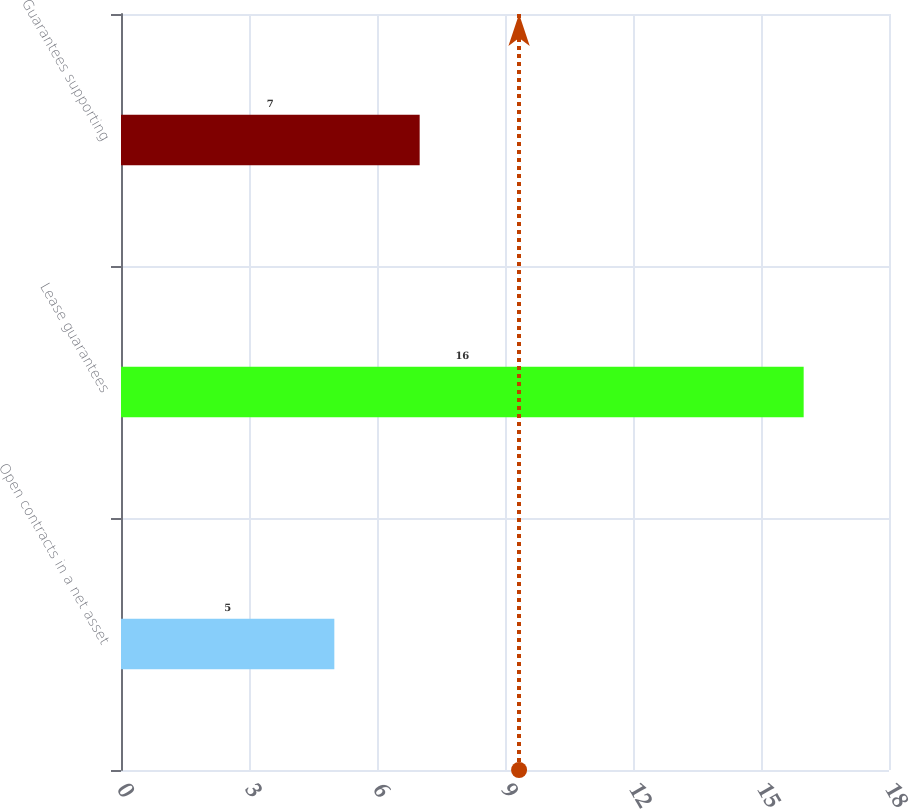<chart> <loc_0><loc_0><loc_500><loc_500><bar_chart><fcel>Open contracts in a net asset<fcel>Lease guarantees<fcel>Guarantees supporting<nl><fcel>5<fcel>16<fcel>7<nl></chart> 